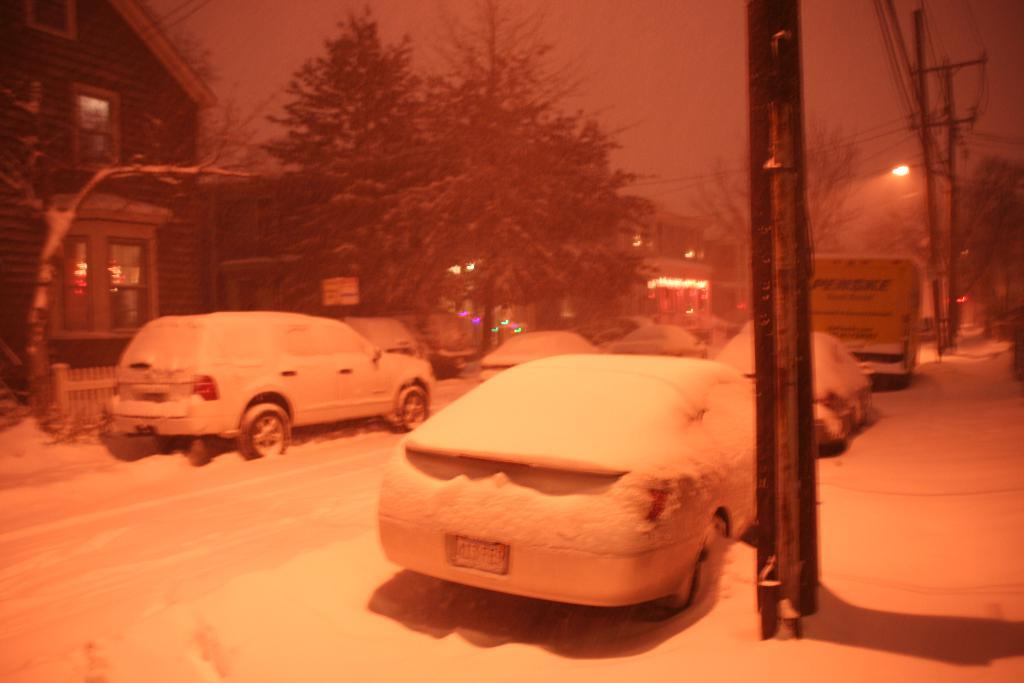What type of vehicles can be seen in the image? There are cars and a vehicle in the image. What other structures are present in the image? There are buildings in the image. What type of vegetation is visible in the image? There are trees in the image. What type of lighting is present in the image? There are pole lights in the image. What weather condition is depicted in the image? There is snow visible in the image. Is there any quicksand visible in the image? No, there is no quicksand present in the image. How much sugar is being used by the cars in the image? There is no sugar involved in the image; it features cars, a vehicle, buildings, trees, pole lights, and snow. 